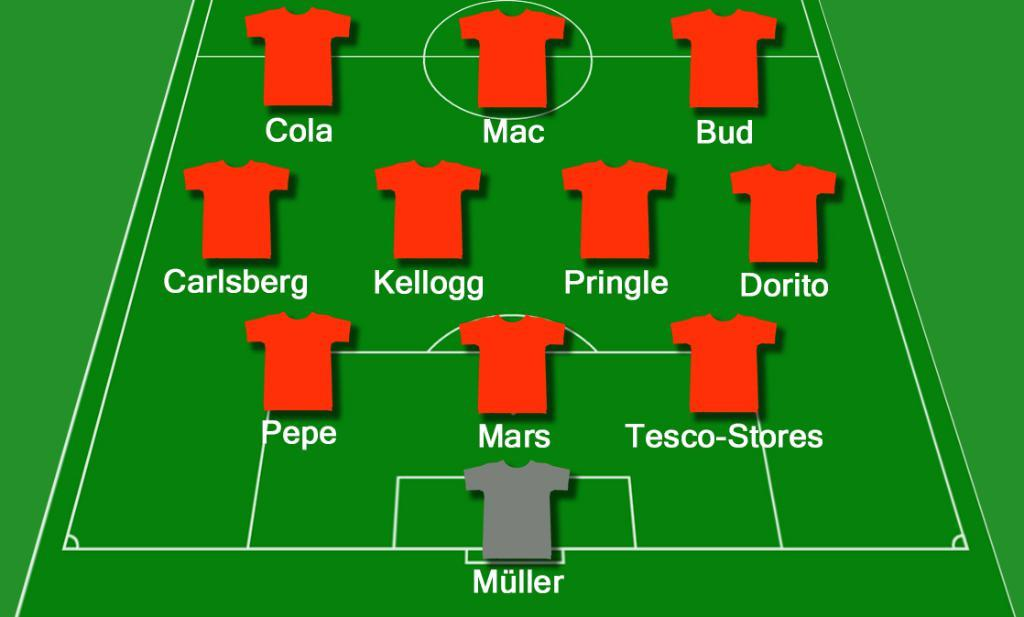<image>
Describe the image concisely. A grey shirt is designated as Muller in the goal. 